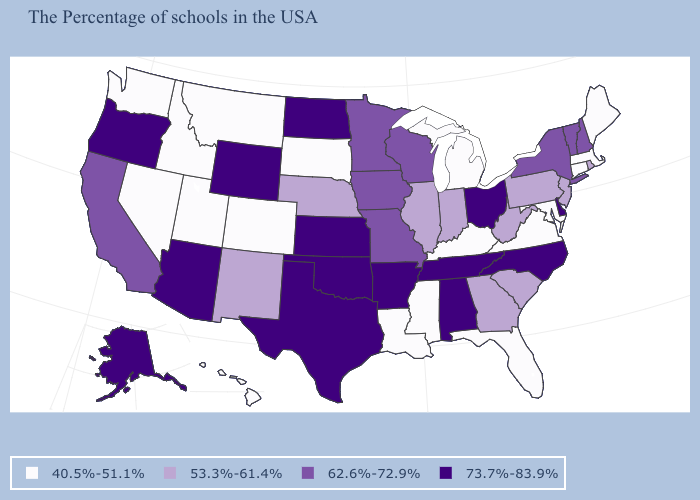How many symbols are there in the legend?
Concise answer only. 4. Does North Carolina have the same value as Oregon?
Answer briefly. Yes. What is the highest value in the South ?
Quick response, please. 73.7%-83.9%. What is the value of North Dakota?
Be succinct. 73.7%-83.9%. What is the value of New Jersey?
Write a very short answer. 53.3%-61.4%. Among the states that border South Carolina , does North Carolina have the lowest value?
Quick response, please. No. What is the value of Washington?
Give a very brief answer. 40.5%-51.1%. Does Wisconsin have the highest value in the USA?
Give a very brief answer. No. What is the value of Hawaii?
Quick response, please. 40.5%-51.1%. Does Rhode Island have the highest value in the Northeast?
Short answer required. No. Name the states that have a value in the range 53.3%-61.4%?
Keep it brief. Rhode Island, New Jersey, Pennsylvania, South Carolina, West Virginia, Georgia, Indiana, Illinois, Nebraska, New Mexico. What is the lowest value in the USA?
Short answer required. 40.5%-51.1%. Does Utah have the highest value in the West?
Quick response, please. No. Does Connecticut have the highest value in the Northeast?
Keep it brief. No. Does Pennsylvania have a higher value than Mississippi?
Write a very short answer. Yes. 